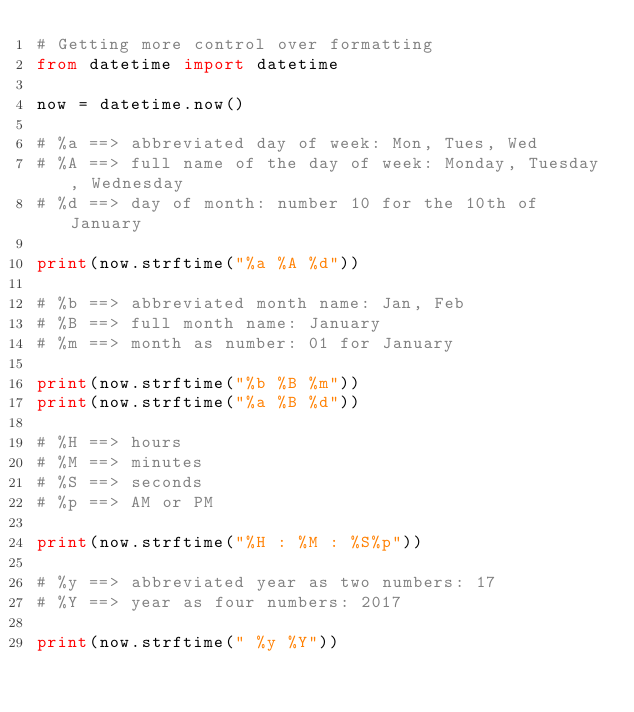Convert code to text. <code><loc_0><loc_0><loc_500><loc_500><_Python_># Getting more control over formatting
from datetime import datetime

now = datetime.now()

# %a ==> abbreviated day of week: Mon, Tues, Wed
# %A ==> full name of the day of week: Monday, Tuesday, Wednesday
# %d ==> day of month: number 10 for the 10th of January

print(now.strftime("%a %A %d"))

# %b ==> abbreviated month name: Jan, Feb
# %B ==> full month name: January
# %m ==> month as number: 01 for January

print(now.strftime("%b %B %m"))
print(now.strftime("%a %B %d"))

# %H ==> hours
# %M ==> minutes
# %S ==> seconds
# %p ==> AM or PM

print(now.strftime("%H : %M : %S%p"))

# %y ==> abbreviated year as two numbers: 17
# %Y ==> year as four numbers: 2017

print(now.strftime(" %y %Y"))</code> 